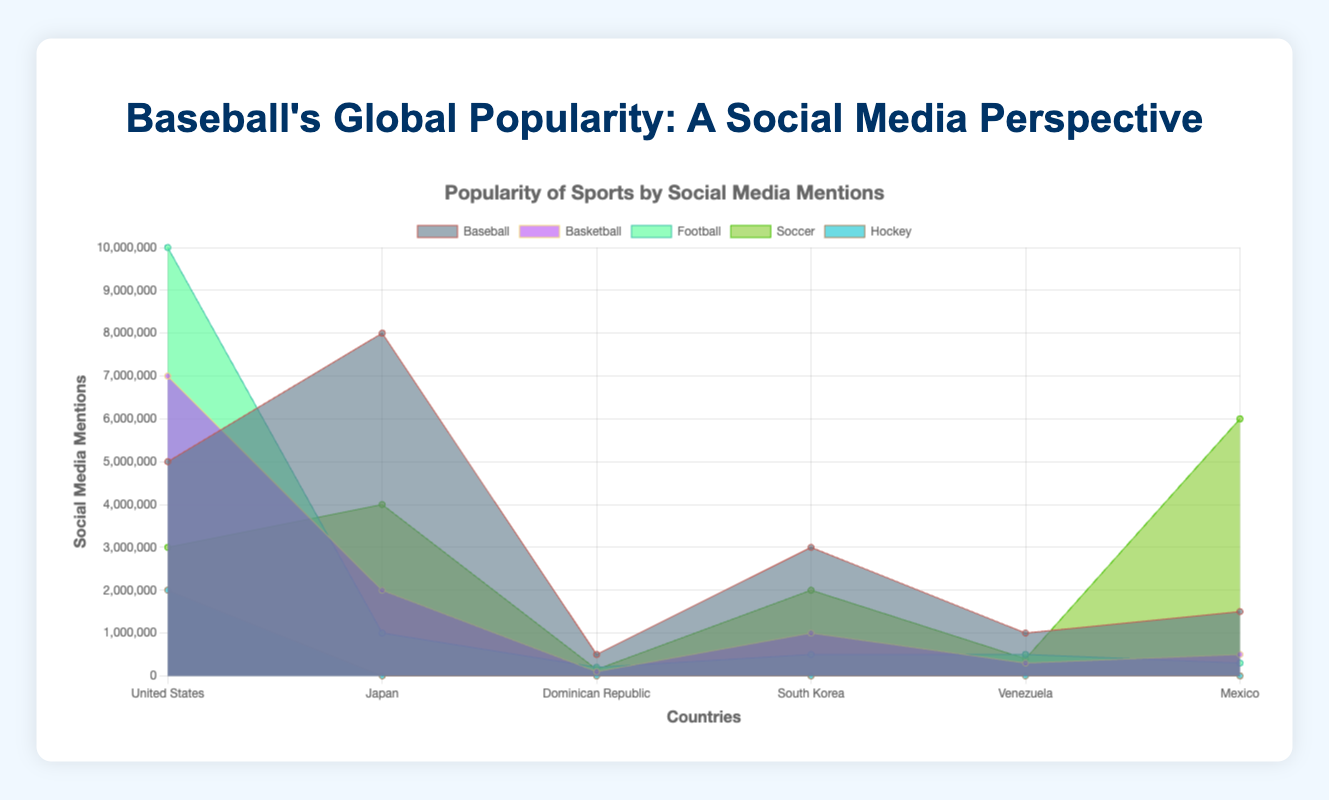What's the title of the figure? The title of the figure is typically written prominently at the top of the chart. In this case, it is stated in the code within the `<h1>` tags.
Answer: Baseball's Global Popularity: A Social Media Perspective Which country has the highest social media mentions for baseball? By observing the height of the areas representing different sports within the colored sections, the country with the tallest section for baseball indicates the highest mentions. Japan has the tallest section for baseball.
Answer: Japan How many countries' social media mentions include the sport Esports? Look at the different colored areas for Esports and count how many countries have this segment. Esports appear only in South Korea.
Answer: 1 Which country has the highest total number of social media mentions for all sports combined? Sum up the areas of all sports mentions for each country and compare them. The United States has the highest total number of mentions when all sports areas are combined.
Answer: United States What is the difference in the number of social media mentions for baseball between Japan and the United States? Subtract the number of social media mentions for baseball in the United States from those in Japan. Japan (8000000) - United States (5000000) = 3000000.
Answer: 3000000 Which sport has the lowest social media mentions in the Dominican Republic? Observe the height of the areas representing different sports in the Dominican Republic section. Volleyball and Basketball both are the lowest with 100000 mentions each.
Answer: Volleyball and Basketball Compare the popularity of baseball and soccer in Mexico based on social media mentions. Which has more mentions and by how much? Subtract the number of social media mentions for soccer from those for baseball in Mexico. Soccer (6000000) - Baseball (1500000) = 4500000. Soccer is more popular by 4500000 mentions.
Answer: Soccer by 4500000 In South Korea, which sport has more social media mentions: Baseball or Esports? Compare the heights of the corresponding areas for Baseball and Esports in South Korea. Esports have more mentions than Baseball.
Answer: Esports Among the countries listed, which country has the least social media mentions for basketball, and what is that number? Look at the areas corresponding to Basketball for all countries and identify the smallest area. The Dominican Republic has the least mentions for basketball with 100000.
Answer: Dominican Republic with 100000 What is the average number of social media mentions for baseball across all the countries? Sum up the social media mentions for all countries and divide by the number of countries. (5000000 + 8000000 + 500000 + 3000000 + 1000000 + 1500000) / 6 = 3166666.67.
Answer: 3166667 